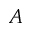<formula> <loc_0><loc_0><loc_500><loc_500>A</formula> 